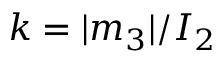<formula> <loc_0><loc_0><loc_500><loc_500>k = | m _ { 3 } | / I _ { 2 }</formula> 